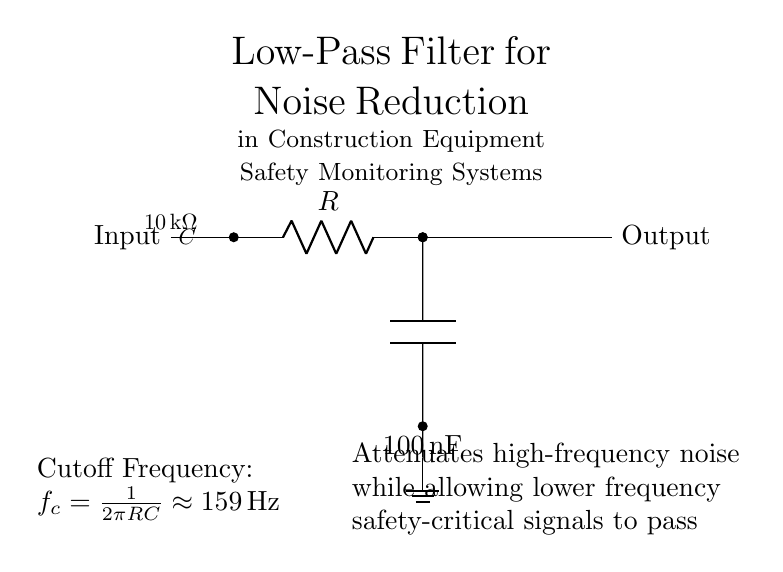What type of filter is depicted in the circuit? The circuit diagram shows a low-pass filter, as indicated by the labeling above the components and its configuration, which allows low-frequency signals to pass while attenuating higher frequencies.
Answer: low-pass filter What is the resistance value in the circuit? The resistance value can be found labeled on the resistor in the diagram, which states it is ten thousand ohms (10k ohm).
Answer: 10 kilo-ohms What is the capacitance value in the circuit? The capacitance is indicated in the diagram next to the capacitor symbol, denoting it as one hundred nanofarads (100nF).
Answer: 100 nanofarads What is the cutoff frequency of the filter? The cutoff frequency is calculated based on the resistor and capacitor values and is explicitly stated in the diagram as approximately 159 hertz.
Answer: 159 hertz How does the circuit affect high-frequency signals? The circuit is designed to attenuate high-frequency noise, allowing lower frequency safety-critical signals to pass through, as described in the explanatory text.
Answer: Attenuates What does the notation "ground" indicate in this circuit? The notation "ground" indicates a reference point in the circuit for voltage measurements and serves as a common return path for electric current, ensuring safety and proper functionality.
Answer: Reference point Why is it important to use a low-pass filter in construction equipment safety monitoring systems? A low-pass filter is critical in these systems because it helps reduce unwanted high-frequency noise that could obscure important low-frequency signals relevant to safety, ensuring reliable monitoring.
Answer: Noise reduction 